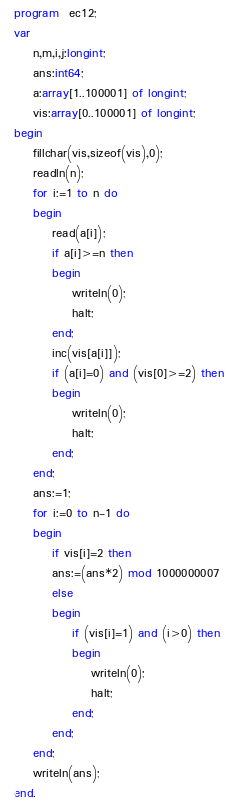<code> <loc_0><loc_0><loc_500><loc_500><_Pascal_>program  ec12;
var 
	n,m,i,j:longint;
	ans:int64;
	a:array[1..100001] of longint;
	vis:array[0..100001] of longint;
begin 
	fillchar(vis,sizeof(vis),0);
	readln(n);
	for i:=1 to n do 
	begin 
		read(a[i]);
		if a[i]>=n then 
		begin 
			writeln(0);
			halt;
		end;
		inc(vis[a[i]]);
		if (a[i]=0) and (vis[0]>=2) then 
		begin 
			writeln(0);
			halt;
		end;
	end; 
	ans:=1;
	for i:=0 to n-1 do 
	begin 
		if vis[i]=2 then 
		ans:=(ans*2) mod 1000000007
		else
		begin 
			if (vis[i]=1) and (i>0) then 
			begin 
				writeln(0);
				halt;
			end;
		end;
	end;
	writeln(ans);
end. </code> 